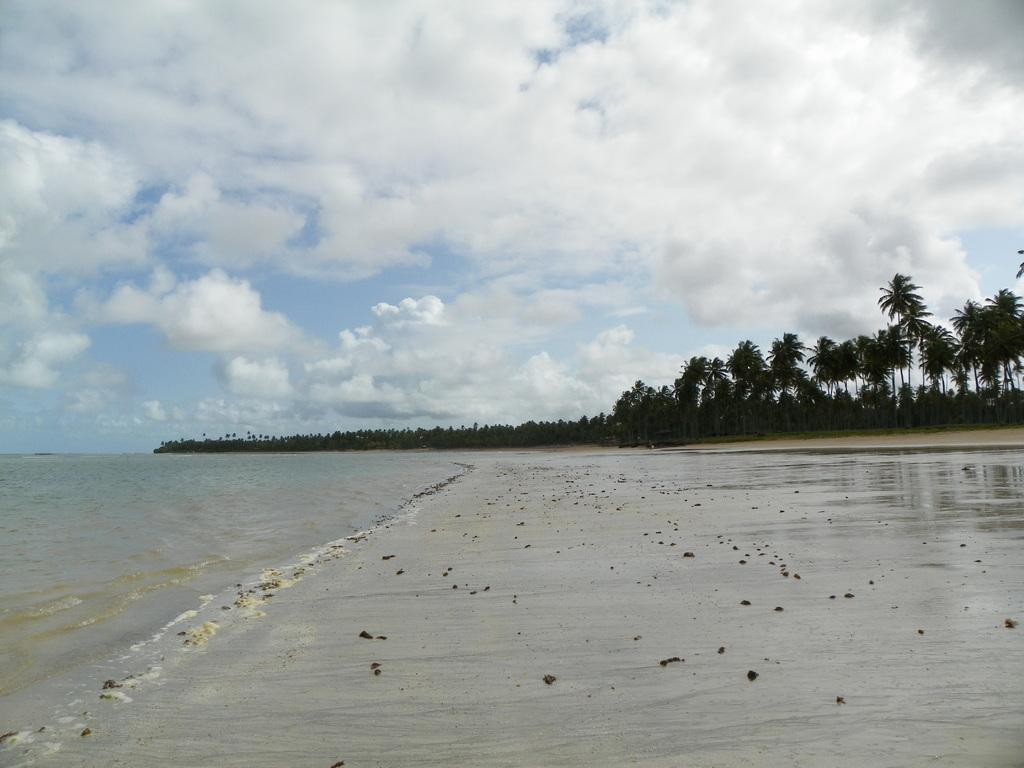What type of vegetation can be seen in the image? There are trees in the image. What natural element is visible besides the trees? There is water visible in the image. What colors can be seen in the sky in the image? The sky is blue and white in color. What type of engine can be seen powering the boat in the image? There is no boat or engine present in the image; it only features trees, water, and a blue and white sky. 